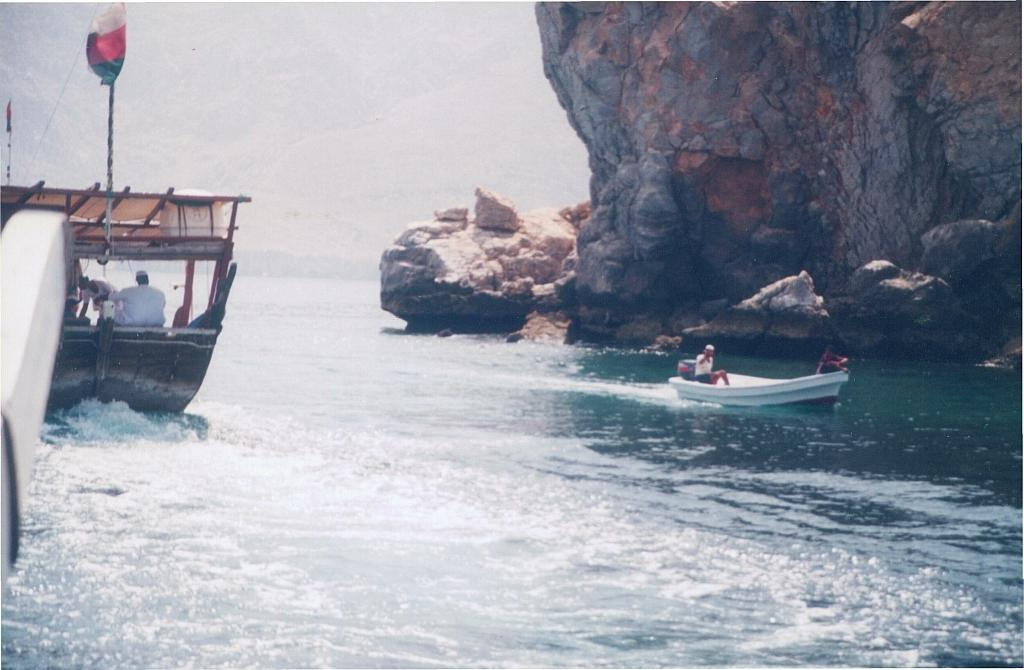How many boats are in the image? There are two boats in the image. Where are the boats located? The boats are on the water. What can be seen in the boats? There are people sitting in the boats. What is visible in the background of the image? The sky, clouds, water, a hill, and a flag are visible in the background of the image. What type of mask is being worn by the people in the boats? There is no mention of masks in the image, so it cannot be determined if any are being worn. 